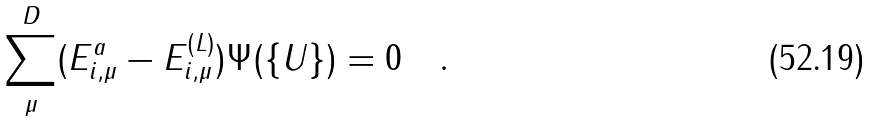<formula> <loc_0><loc_0><loc_500><loc_500>\sum _ { \mu } ^ { D } ( E ^ { a } _ { i , \mu } - E ^ { ( L ) } _ { i , \mu } ) \Psi ( \{ U \} ) = 0 \quad .</formula> 